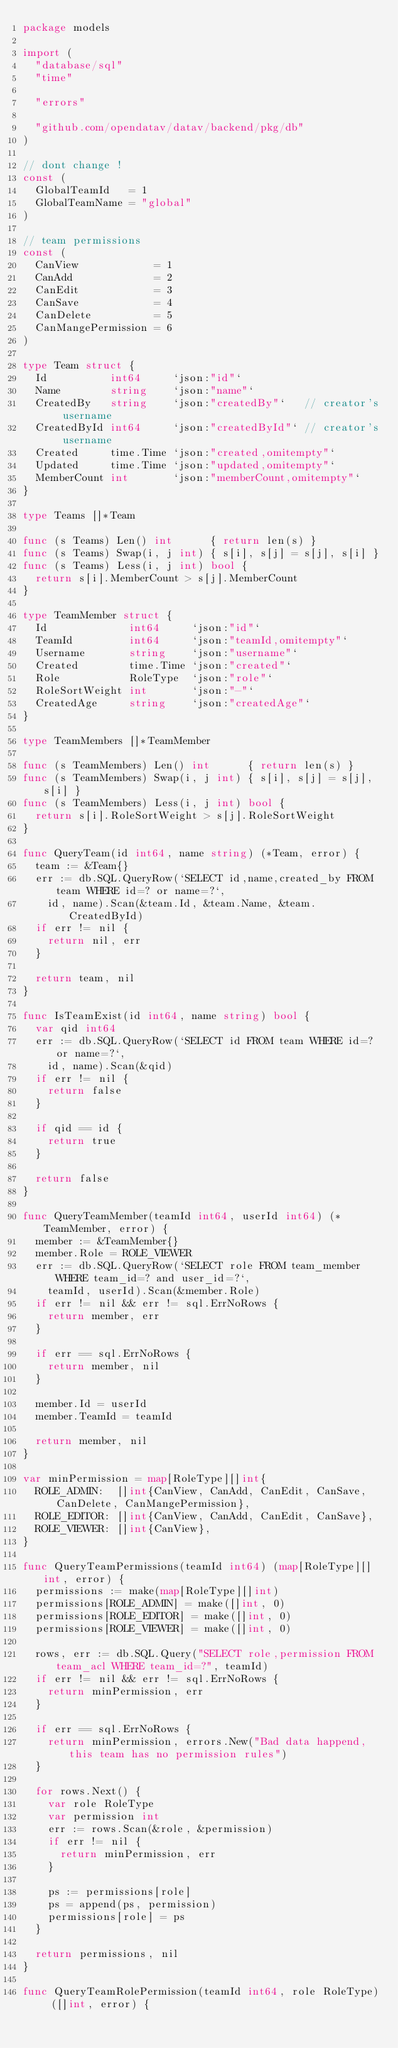<code> <loc_0><loc_0><loc_500><loc_500><_Go_>package models

import (
	"database/sql"
	"time"

	"errors"

	"github.com/opendatav/datav/backend/pkg/db"
)

// dont change !
const (
	GlobalTeamId   = 1
	GlobalTeamName = "global"
)

// team permissions
const (
	CanView            = 1
	CanAdd             = 2
	CanEdit            = 3
	CanSave            = 4
	CanDelete          = 5
	CanMangePermission = 6
)

type Team struct {
	Id          int64     `json:"id"`
	Name        string    `json:"name"`
	CreatedBy   string    `json:"createdBy"`   // creator's username
	CreatedById int64     `json:"createdById"` // creator's username
	Created     time.Time `json:"created,omitempty"`
	Updated     time.Time `json:"updated,omitempty"`
	MemberCount int       `json:"memberCount,omitempty"`
}

type Teams []*Team

func (s Teams) Len() int      { return len(s) }
func (s Teams) Swap(i, j int) { s[i], s[j] = s[j], s[i] }
func (s Teams) Less(i, j int) bool {
	return s[i].MemberCount > s[j].MemberCount
}

type TeamMember struct {
	Id             int64     `json:"id"`
	TeamId         int64     `json:"teamId,omitempty"`
	Username       string    `json:"username"`
	Created        time.Time `json:"created"`
	Role           RoleType  `json:"role"`
	RoleSortWeight int       `json:"-"`
	CreatedAge     string    `json:"createdAge"`
}

type TeamMembers []*TeamMember

func (s TeamMembers) Len() int      { return len(s) }
func (s TeamMembers) Swap(i, j int) { s[i], s[j] = s[j], s[i] }
func (s TeamMembers) Less(i, j int) bool {
	return s[i].RoleSortWeight > s[j].RoleSortWeight
}

func QueryTeam(id int64, name string) (*Team, error) {
	team := &Team{}
	err := db.SQL.QueryRow(`SELECT id,name,created_by FROM team WHERE id=? or name=?`,
		id, name).Scan(&team.Id, &team.Name, &team.CreatedById)
	if err != nil {
		return nil, err
	}

	return team, nil
}

func IsTeamExist(id int64, name string) bool {
	var qid int64
	err := db.SQL.QueryRow(`SELECT id FROM team WHERE id=? or name=?`,
		id, name).Scan(&qid)
	if err != nil {
		return false
	}

	if qid == id {
		return true
	}

	return false
}

func QueryTeamMember(teamId int64, userId int64) (*TeamMember, error) {
	member := &TeamMember{}
	member.Role = ROLE_VIEWER
	err := db.SQL.QueryRow(`SELECT role FROM team_member WHERE team_id=? and user_id=?`,
		teamId, userId).Scan(&member.Role)
	if err != nil && err != sql.ErrNoRows {
		return member, err
	}

	if err == sql.ErrNoRows {
		return member, nil
	}

	member.Id = userId
	member.TeamId = teamId

	return member, nil
}

var minPermission = map[RoleType][]int{
	ROLE_ADMIN:  []int{CanView, CanAdd, CanEdit, CanSave, CanDelete, CanMangePermission},
	ROLE_EDITOR: []int{CanView, CanAdd, CanEdit, CanSave},
	ROLE_VIEWER: []int{CanView},
}

func QueryTeamPermissions(teamId int64) (map[RoleType][]int, error) {
	permissions := make(map[RoleType][]int)
	permissions[ROLE_ADMIN] = make([]int, 0)
	permissions[ROLE_EDITOR] = make([]int, 0)
	permissions[ROLE_VIEWER] = make([]int, 0)

	rows, err := db.SQL.Query("SELECT role,permission FROM team_acl WHERE team_id=?", teamId)
	if err != nil && err != sql.ErrNoRows {
		return minPermission, err
	}

	if err == sql.ErrNoRows {
		return minPermission, errors.New("Bad data happend, this team has no permission rules")
	}

	for rows.Next() {
		var role RoleType
		var permission int
		err := rows.Scan(&role, &permission)
		if err != nil {
			return minPermission, err
		}

		ps := permissions[role]
		ps = append(ps, permission)
		permissions[role] = ps
	}

	return permissions, nil
}

func QueryTeamRolePermission(teamId int64, role RoleType) ([]int, error) {</code> 